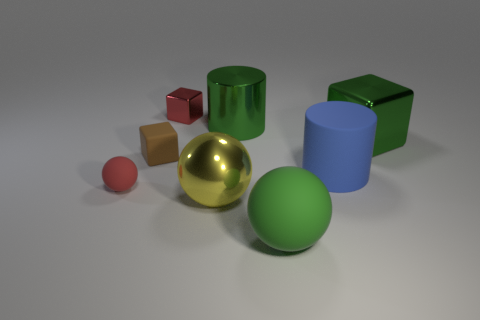Is the material of the red sphere the same as the green cube?
Your answer should be very brief. No. Is there a large green metal block that is behind the big rubber object that is in front of the small sphere?
Offer a terse response. Yes. How many objects are both left of the large blue matte cylinder and in front of the small brown rubber cube?
Give a very brief answer. 3. What shape is the object that is to the left of the brown cube?
Your answer should be very brief. Sphere. How many metal cylinders are the same size as the blue object?
Make the answer very short. 1. Does the large rubber thing that is in front of the big yellow shiny sphere have the same color as the big shiny cube?
Your answer should be compact. Yes. There is a object that is left of the big yellow metallic sphere and in front of the small rubber cube; what is its material?
Offer a terse response. Rubber. Is the number of green cylinders greater than the number of purple metal objects?
Your answer should be very brief. Yes. The small block that is behind the green thing on the left side of the green thing that is in front of the big yellow metal sphere is what color?
Keep it short and to the point. Red. Do the red object that is behind the red matte thing and the brown thing have the same material?
Offer a very short reply. No. 